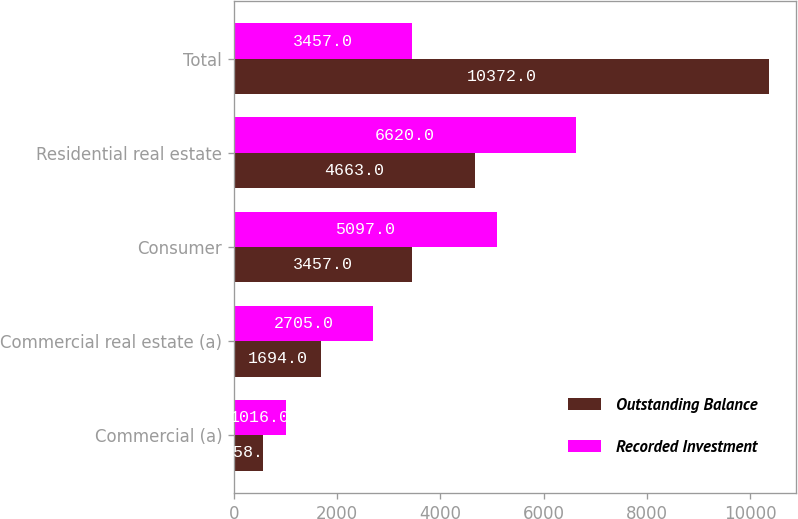Convert chart to OTSL. <chart><loc_0><loc_0><loc_500><loc_500><stacked_bar_chart><ecel><fcel>Commercial (a)<fcel>Commercial real estate (a)<fcel>Consumer<fcel>Residential real estate<fcel>Total<nl><fcel>Outstanding Balance<fcel>558<fcel>1694<fcel>3457<fcel>4663<fcel>10372<nl><fcel>Recorded Investment<fcel>1016<fcel>2705<fcel>5097<fcel>6620<fcel>3457<nl></chart> 